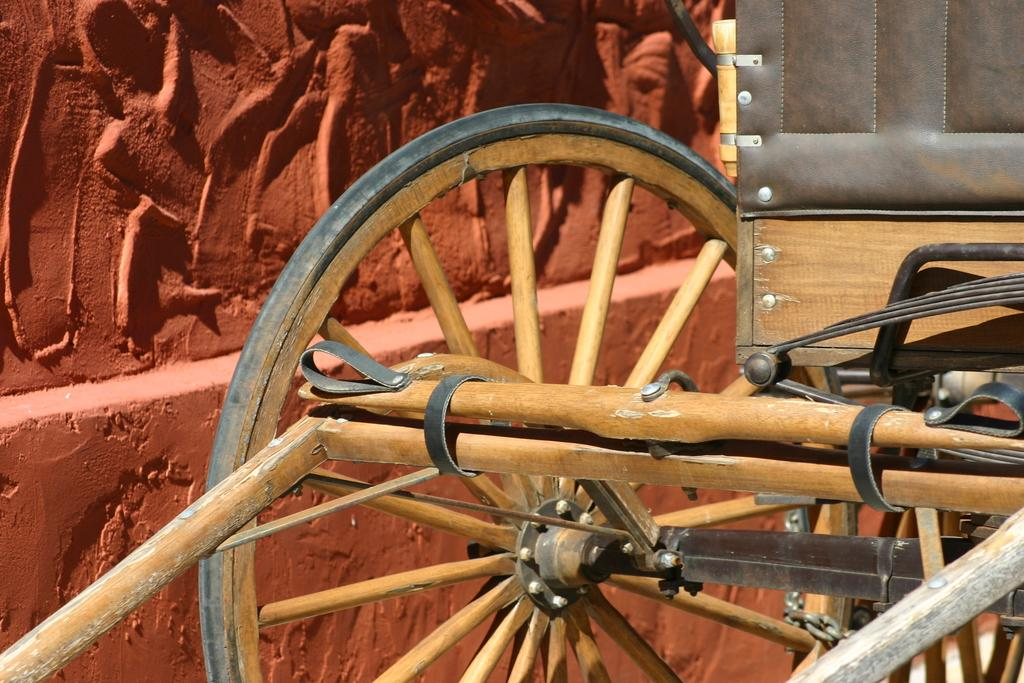What is the main object in the middle of the image? There is a cart in the middle of the image. What can be seen on the left side of the image? There is a wall on the left side of the image. Where is the throne located in the image? There is no throne present in the image. How many soldiers are in the army depicted in the image? There is no army depicted in the image. 